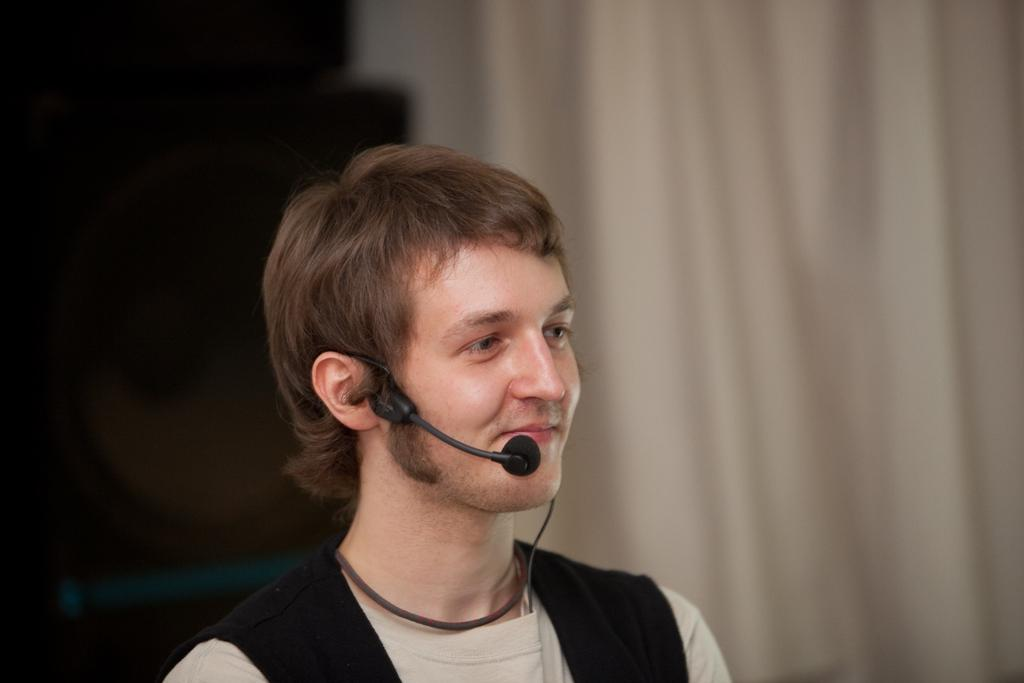Who is present in the image? There is a man in the image. What is the man wearing? The man is wearing a cream t-shirt. What is the man holding in the image? The man is holding a microphone. What can be seen in the background of the image? There is a curtain in the background of the image. Can you describe any objects on the left side of the image? There might be speakers on the left side of the image. How many brothers does the man in the image have? There is no information about the man's brothers in the image, so it cannot be determined. 